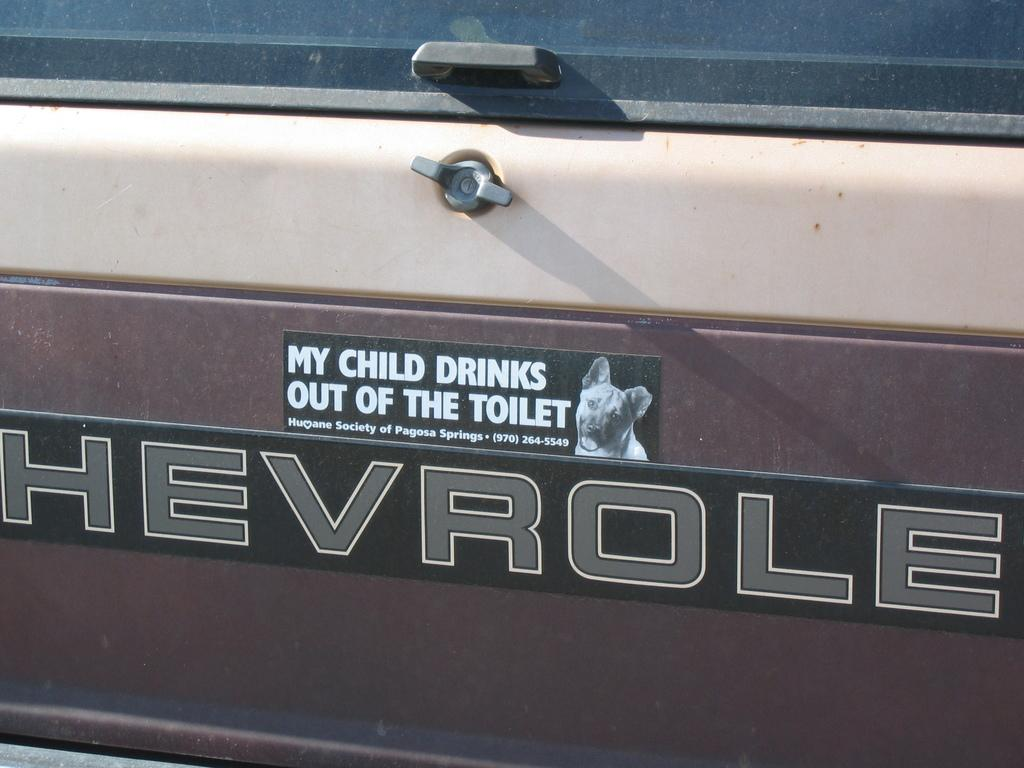What is the main subject of the image? The main subject of the image is the backside of a car. Can you describe any specific features of the car? Unfortunately, the provided facts do not mention any specific features of the car. Is there any other object or element visible in the image besides the car? The facts do not mention any other objects or elements in the image. How many cows are grazing in the backseat of the car in the image? There are no cows present in the image, as it only shows the backside of a car. What type of roll can be seen on the roof of the car in the image? There is no roll visible on the roof of the car in the image, as the facts do not mention any additional objects or elements. 